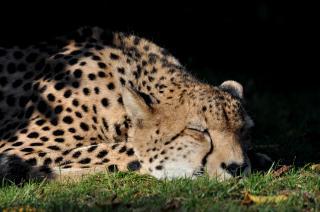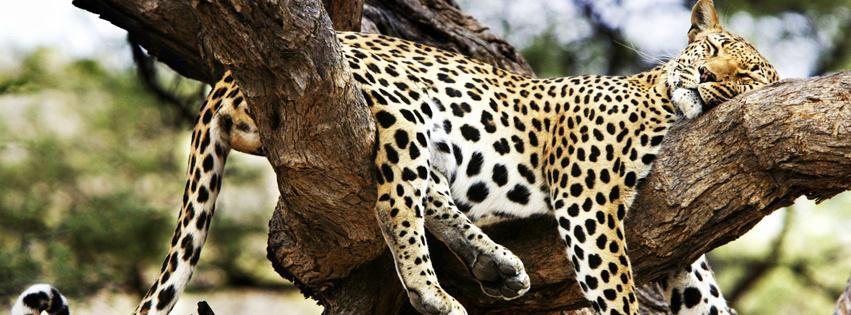The first image is the image on the left, the second image is the image on the right. Considering the images on both sides, is "There is a cheetah sleeping in a tree" valid? Answer yes or no. Yes. The first image is the image on the left, the second image is the image on the right. Analyze the images presented: Is the assertion "There is one cheetah sleeping in a tree." valid? Answer yes or no. Yes. 